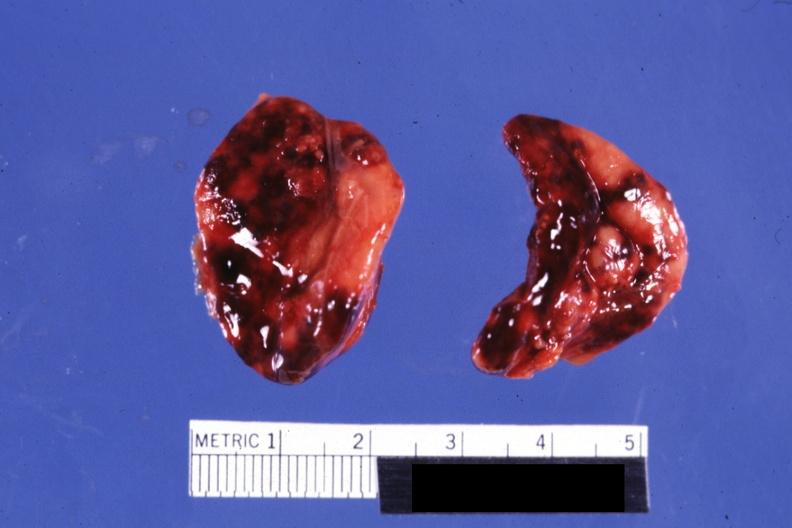where does this belong to?
Answer the question using a single word or phrase. Endocrine system 